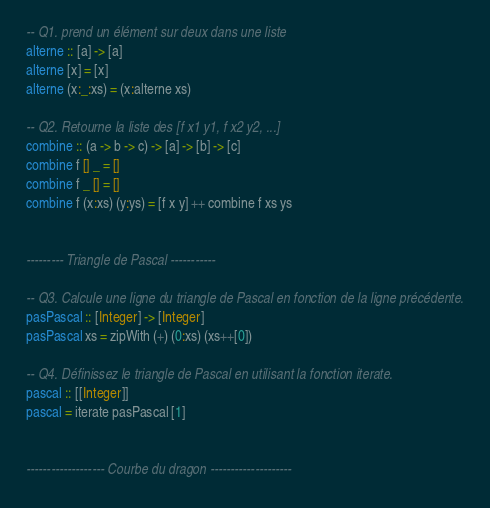Convert code to text. <code><loc_0><loc_0><loc_500><loc_500><_Haskell_>-- Q1. prend un élément sur deux dans une liste
alterne :: [a] -> [a]
alterne [x] = [x]
alterne (x:_:xs) = (x:alterne xs)

-- Q2. Retourne la liste des [f x1 y1, f x2 y2, ...]
combine :: (a -> b -> c) -> [a] -> [b] -> [c]
combine f [] _ = []
combine f _ [] = []
combine f (x:xs) (y:ys) = [f x y] ++ combine f xs ys 


--------- Triangle de Pascal -----------

-- Q3. Calcule une ligne du triangle de Pascal en fonction de la ligne précédente.
pasPascal :: [Integer] -> [Integer]
pasPascal xs = zipWith (+) (0:xs) (xs++[0])

-- Q4. Définissez le triangle de Pascal en utilisant la fonction iterate.
pascal :: [[Integer]]
pascal = iterate pasPascal [1]


------------------- Courbe du dragon --------------------
</code> 